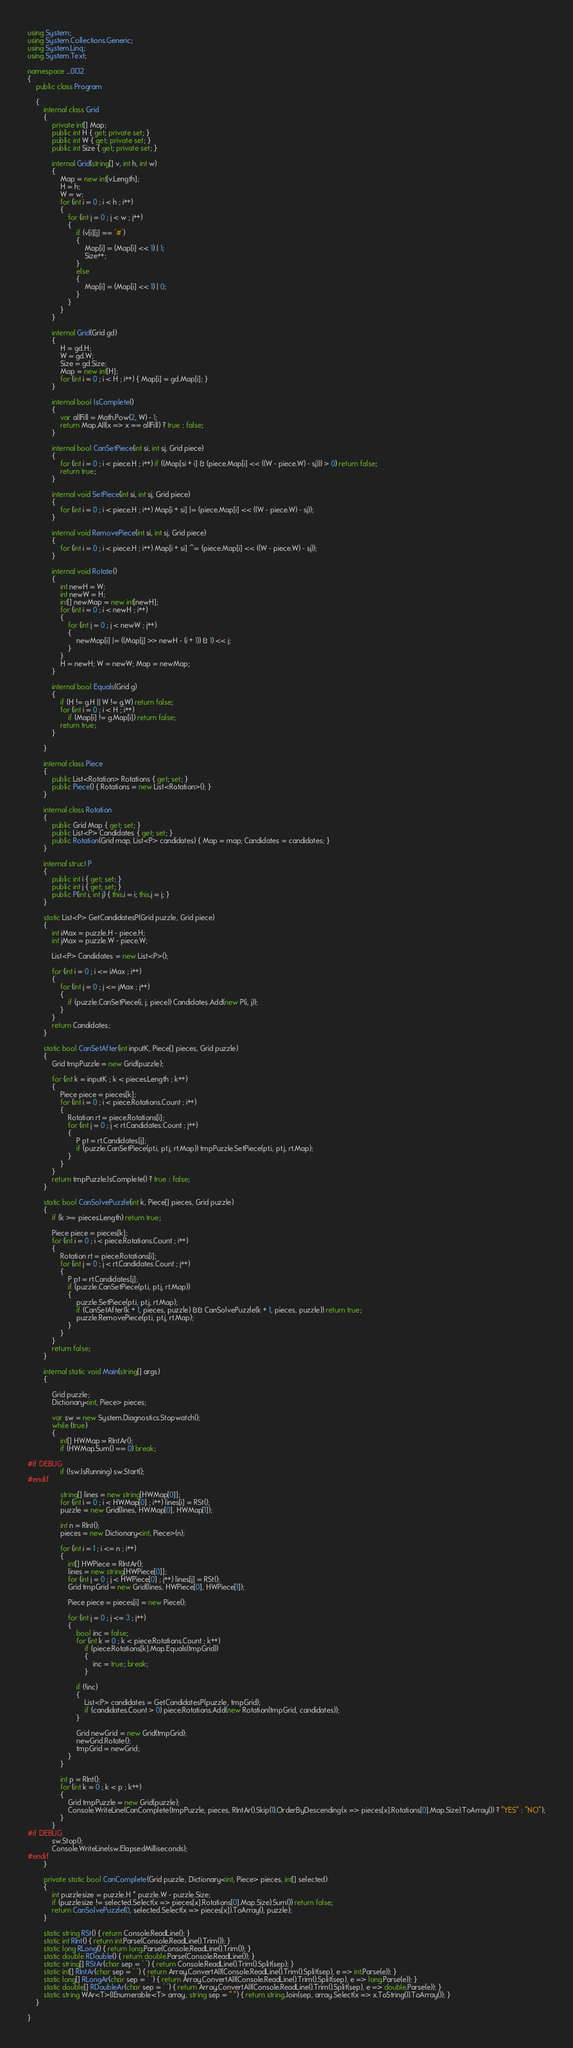Convert code to text. <code><loc_0><loc_0><loc_500><loc_500><_C#_>using System;
using System.Collections.Generic;
using System.Linq;
using System.Text;

namespace _0132
{
    public class Program

    {
        internal class Grid
        {
            private int[] Map;
            public int H { get; private set; }
            public int W { get; private set; }
            public int Size { get; private set; }

            internal Grid(string[] v, int h, int w)
            {
                Map = new int[v.Length];
                H = h;
                W = w;
                for (int i = 0 ; i < h ; i++)
                {
                    for (int j = 0 ; j < w ; j++)
                    {
                        if (v[i][j] == '#')
                        {
                            Map[i] = (Map[i] << 1) | 1;
                            Size++;
                        }
                        else
                        {
                            Map[i] = (Map[i] << 1) | 0;
                        }
                    }
                }
            }

            internal Grid(Grid gd)
            {
                H = gd.H;
                W = gd.W;
                Size = gd.Size;
                Map = new int[H];
                for (int i = 0 ; i < H ; i++) { Map[i] = gd.Map[i]; }
            }

            internal bool IsComplete()
            {
                var allFill = Math.Pow(2, W) - 1;
                return Map.All(x => x == allFill) ? true : false;
            }

            internal bool CanSetPiece(int si, int sj, Grid piece)
            {
                for (int i = 0 ; i < piece.H ; i++) if ((Map[si + i] & (piece.Map[i] << ((W - piece.W) - sj))) > 0) return false;
                return true;
            }

            internal void SetPiece(int si, int sj, Grid piece)
            {
                for (int i = 0 ; i < piece.H ; i++) Map[i + si] |= (piece.Map[i] << ((W - piece.W) - sj));
            }

            internal void RemovePiece(int si, int sj, Grid piece)
            {
                for (int i = 0 ; i < piece.H ; i++) Map[i + si] ^= (piece.Map[i] << ((W - piece.W) - sj));
            }

            internal void Rotate()
            {
                int newH = W;
                int newW = H;
                int[] newMap = new int[newH];
                for (int i = 0 ; i < newH ; i++)
                {
                    for (int j = 0 ; j < newW ; j++)
                    {
                        newMap[i] |= ((Map[j] >> newH - (i + 1)) & 1) << j;
                    }
                }
                H = newH; W = newW; Map = newMap;
            }

            internal bool Equals(Grid g)
            {
                if (H != g.H || W != g.W) return false;
                for (int i = 0 ; i < H ; i++)
                    if (Map[i] != g.Map[i]) return false;
                return true;
            }

        }

        internal class Piece
        {
            public List<Rotation> Rotations { get; set; }
            public Piece() { Rotations = new List<Rotation>(); }
        }

        internal class Rotation
        {
            public Grid Map { get; set; }
            public List<P> Candidates { get; set; }
            public Rotation(Grid map, List<P> candidates) { Map = map; Candidates = candidates; }
        }

        internal struct P
        {
            public int i { get; set; }
            public int j { get; set; }
            public P(int i, int j) { this.i = i; this.j = j; }
        }

        static List<P> GetCandidatesP(Grid puzzle, Grid piece)
        {
            int iMax = puzzle.H - piece.H;
            int jMax = puzzle.W - piece.W;

            List<P> Candidates = new List<P>();

            for (int i = 0 ; i <= iMax ; i++)
            {
                for (int j = 0 ; j <= jMax ; j++)
                {
                    if (puzzle.CanSetPiece(i, j, piece)) Candidates.Add(new P(i, j));
                }
            }
            return Candidates;
        }

        static bool CanSetAfter(int inputK, Piece[] pieces, Grid puzzle)
        {
            Grid tmpPuzzle = new Grid(puzzle);

            for (int k = inputK ; k < pieces.Length ; k++)
            {
                Piece piece = pieces[k];
                for (int i = 0 ; i < piece.Rotations.Count ; i++)
                {
                    Rotation rt = piece.Rotations[i];
                    for (int j = 0 ; j < rt.Candidates.Count ; j++)
                    {
                        P pt = rt.Candidates[j];
                        if (puzzle.CanSetPiece(pt.i, pt.j, rt.Map)) tmpPuzzle.SetPiece(pt.i, pt.j, rt.Map);
                    }
                }
            }
            return tmpPuzzle.IsComplete() ? true : false;
        }

        static bool CanSolvePuzzle(int k, Piece[] pieces, Grid puzzle)
        {
            if (k >= pieces.Length) return true;

            Piece piece = pieces[k];
            for (int i = 0 ; i < piece.Rotations.Count ; i++)
            {
                Rotation rt = piece.Rotations[i];
                for (int j = 0 ; j < rt.Candidates.Count ; j++)
                {
                    P pt = rt.Candidates[j];
                    if (puzzle.CanSetPiece(pt.i, pt.j, rt.Map))
                    {
                        puzzle.SetPiece(pt.i, pt.j, rt.Map);
                        if (CanSetAfter(k + 1, pieces, puzzle) && CanSolvePuzzle(k + 1, pieces, puzzle)) return true;
                        puzzle.RemovePiece(pt.i, pt.j, rt.Map);
                    }
                }
            }
            return false;
        }

        internal static void Main(string[] args)
        {

            Grid puzzle;
            Dictionary<int, Piece> pieces;

            var sw = new System.Diagnostics.Stopwatch();
            while (true)
            {
                int[] HWMap = RIntAr();
                if (HWMap.Sum() == 0) break;

#if DEBUG
                if (!sw.IsRunning) sw.Start();
#endif

                string[] lines = new string[HWMap[0]];
                for (int i = 0 ; i < HWMap[0] ; i++) lines[i] = RSt();
                puzzle = new Grid(lines, HWMap[0], HWMap[1]);

                int n = RInt();
                pieces = new Dictionary<int, Piece>(n);

                for (int i = 1 ; i <= n ; i++)
                {
                    int[] HWPiece = RIntAr();
                    lines = new string[HWPiece[0]];
                    for (int j = 0 ; j < HWPiece[0] ; j++) lines[j] = RSt();
                    Grid tmpGrid = new Grid(lines, HWPiece[0], HWPiece[1]);

                    Piece piece = pieces[i] = new Piece();

                    for (int j = 0 ; j <= 3 ; j++)
                    {
                        bool inc = false;
                        for (int k = 0 ; k < piece.Rotations.Count ; k++)
                            if (piece.Rotations[k].Map.Equals(tmpGrid))
                            {
                                inc = true; break;
                            }

                        if (!inc)
                        {
                            List<P> candidates = GetCandidatesP(puzzle, tmpGrid);
                            if (candidates.Count > 0) piece.Rotations.Add(new Rotation(tmpGrid, candidates));
                        }

                        Grid newGrid = new Grid(tmpGrid);
                        newGrid.Rotate();
                        tmpGrid = newGrid;
                    }
                }

                int p = RInt();
                for (int k = 0 ; k < p ; k++)
                {
                    Grid tmpPuzzle = new Grid(puzzle);
                    Console.WriteLine(CanComplete(tmpPuzzle, pieces, RIntAr().Skip(1).OrderByDescending(x => pieces[x].Rotations[0].Map.Size).ToArray()) ? "YES" : "NO");
                }
            }
#if DEBUG
            sw.Stop();
            Console.WriteLine(sw.ElapsedMilliseconds);
#endif
        }

        private static bool CanComplete(Grid puzzle, Dictionary<int, Piece> pieces, int[] selected)
        {
            int puzzlesize = puzzle.H * puzzle.W - puzzle.Size;
            if (puzzlesize != selected.Select(x => pieces[x].Rotations[0].Map.Size).Sum()) return false;
            return CanSolvePuzzle(0, selected.Select(x => pieces[x]).ToArray(), puzzle);
        }

        static string RSt() { return Console.ReadLine(); }
        static int RInt() { return int.Parse(Console.ReadLine().Trim()); }
        static long RLong() { return long.Parse(Console.ReadLine().Trim()); }
        static double RDouble() { return double.Parse(Console.ReadLine()); }
        static string[] RStAr(char sep = ' ') { return Console.ReadLine().Trim().Split(sep); }
        static int[] RIntAr(char sep = ' ') { return Array.ConvertAll(Console.ReadLine().Trim().Split(sep), e => int.Parse(e)); }
        static long[] RLongAr(char sep = ' ') { return Array.ConvertAll(Console.ReadLine().Trim().Split(sep), e => long.Parse(e)); }
        static double[] RDoubleAr(char sep = ' ') { return Array.ConvertAll(Console.ReadLine().Trim().Split(sep), e => double.Parse(e)); }
        static string WAr<T>(IEnumerable<T> array, string sep = " ") { return string.Join(sep, array.Select(x => x.ToString()).ToArray()); }
    }

}

</code> 